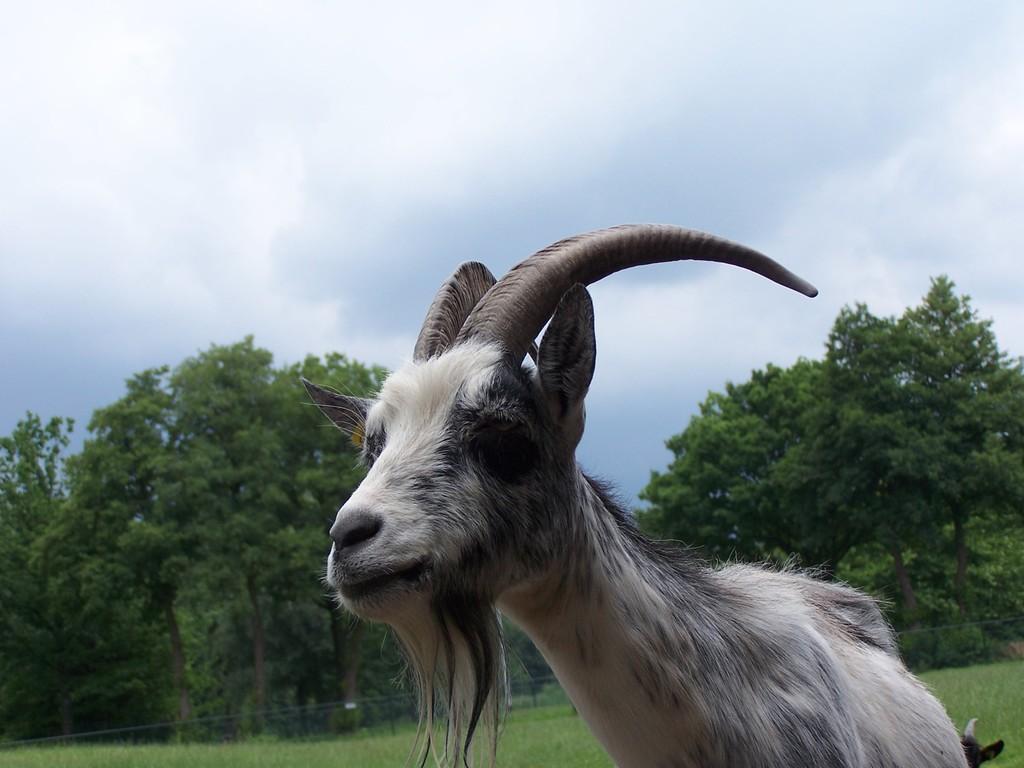Could you give a brief overview of what you see in this image? In this image I can see an animal which is in white and black color. I can see two horns to an animal. It is on the ground. In the back there are many trees, clouds and the blue sky. 